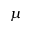Convert formula to latex. <formula><loc_0><loc_0><loc_500><loc_500>\mu</formula> 